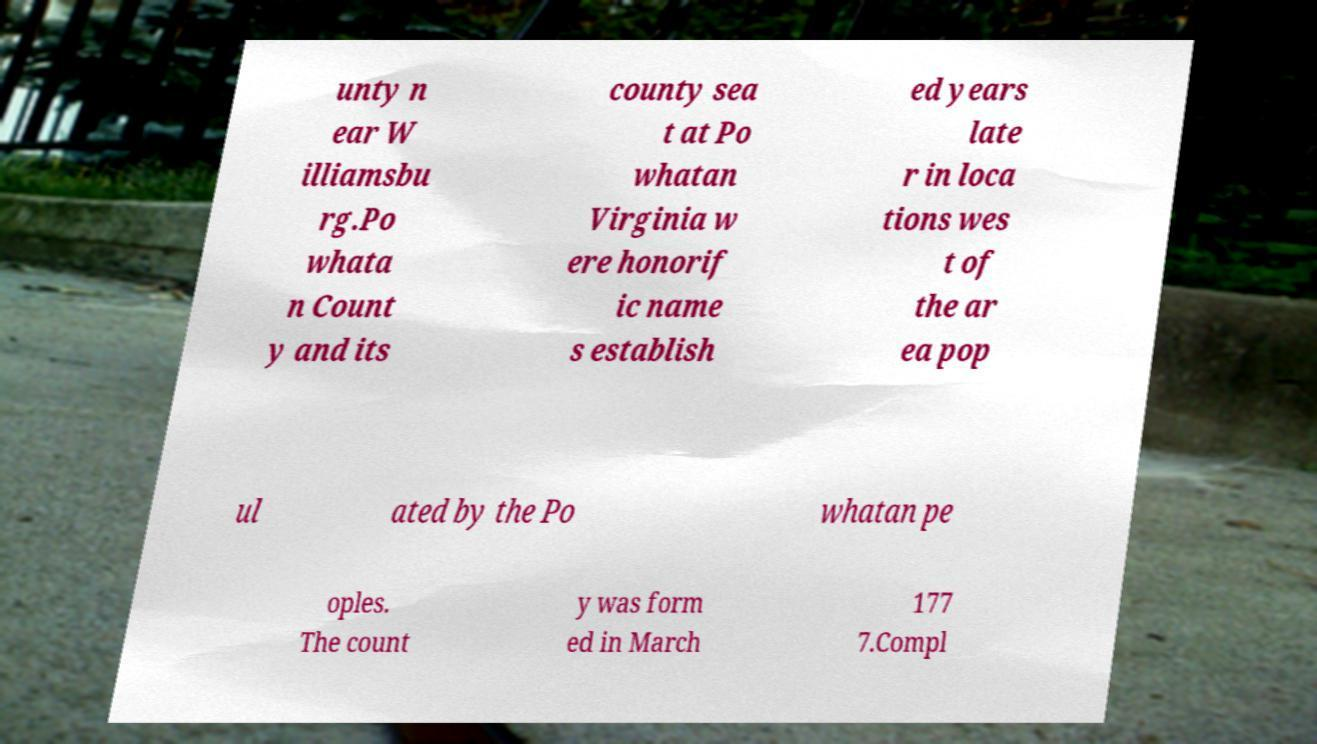What messages or text are displayed in this image? I need them in a readable, typed format. unty n ear W illiamsbu rg.Po whata n Count y and its county sea t at Po whatan Virginia w ere honorif ic name s establish ed years late r in loca tions wes t of the ar ea pop ul ated by the Po whatan pe oples. The count y was form ed in March 177 7.Compl 